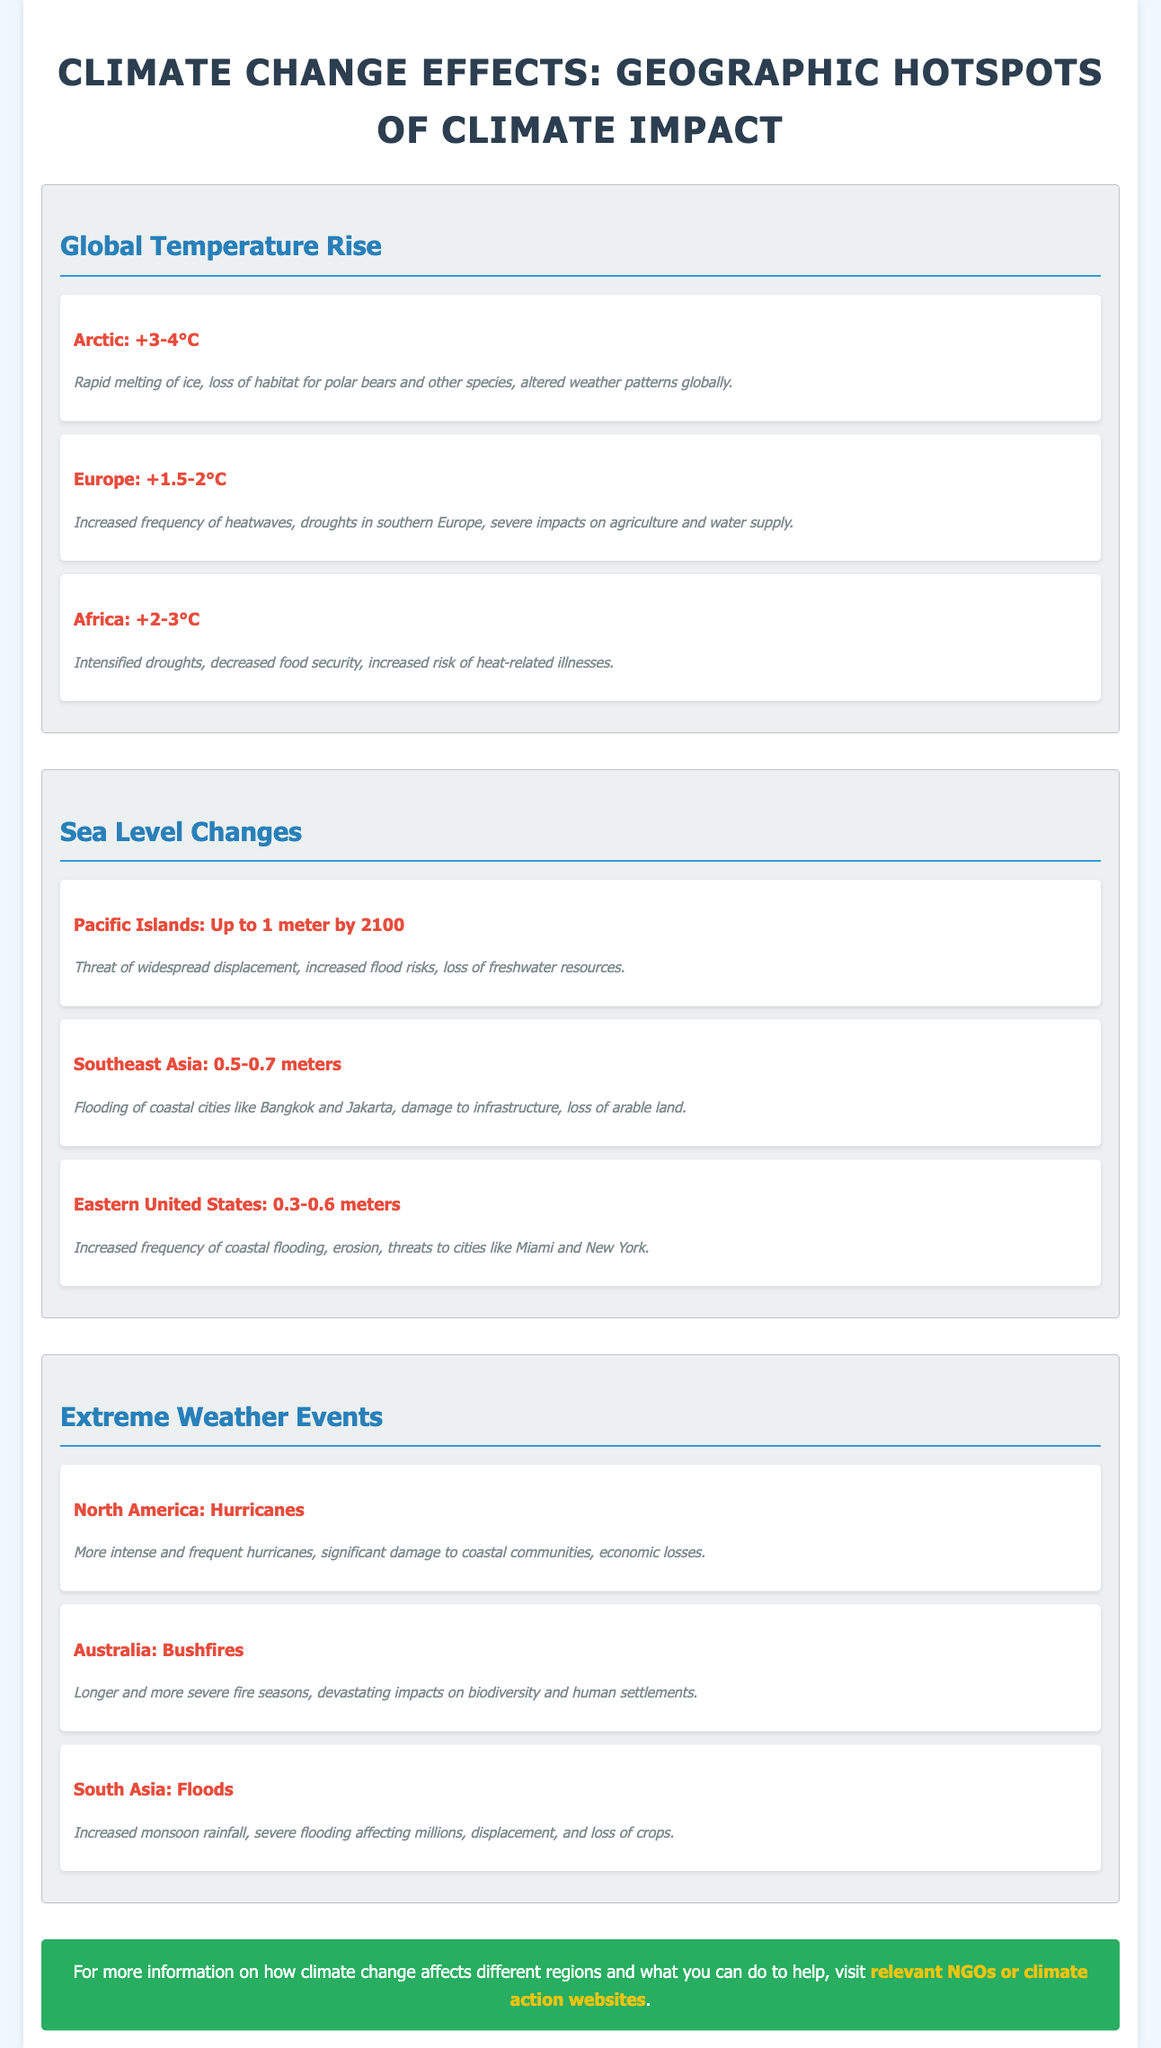What is the temperature rise in the Arctic? The document states that the temperature rise in the Arctic is between +3-4°C.
Answer: +3-4°C What is the expected sea level change in Pacific Islands by 2100? The document lists that the expected sea level change in Pacific Islands could be up to 1 meter by 2100.
Answer: Up to 1 meter Which region is experiencing longer fire seasons? The section on extreme weather events highlights Australia as experiencing longer and more severe fire seasons.
Answer: Australia What type of extreme weather events are mentioned for North America? The document specifies that North America is experiencing hurricanes as extreme weather events.
Answer: Hurricanes What is the impact of temperature rise in Europe? The impact of temperature rise in Europe includes increased frequency of heatwaves and droughts in southern Europe.
Answer: Increased frequency of heatwaves, droughts in southern Europe What is the impact of sea-level changes in Southeast Asia? According to the document, the impact includes flooding of coastal cities like Bangkok and Jakarta.
Answer: Flooding of coastal cities like Bangkok and Jakarta How many degrees Celsius is the temperature rise expected in Africa? The document states the temperature rise in Africa is expected to be +2-3°C.
Answer: +2-3°C Which region faces displacement due to sea level changes? The Pacific Islands are highlighted as facing widespread displacement due to sea level changes.
Answer: Pacific Islands 